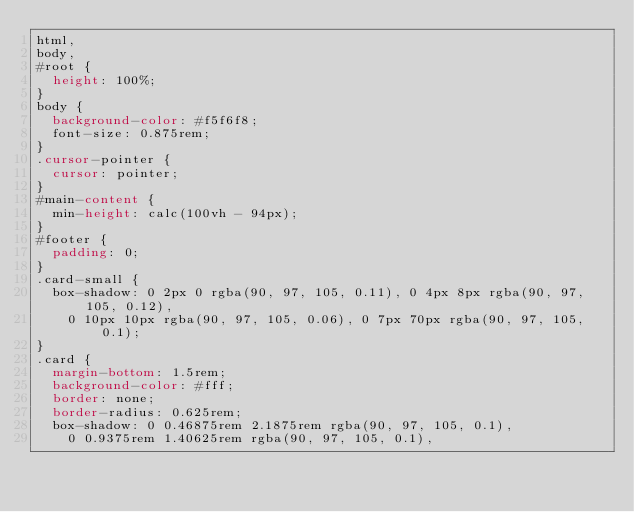<code> <loc_0><loc_0><loc_500><loc_500><_CSS_>html,
body,
#root {
  height: 100%;
}
body {
  background-color: #f5f6f8;
  font-size: 0.875rem;
}
.cursor-pointer {
  cursor: pointer;
}
#main-content {
  min-height: calc(100vh - 94px);
}
#footer {
  padding: 0;
}
.card-small {
  box-shadow: 0 2px 0 rgba(90, 97, 105, 0.11), 0 4px 8px rgba(90, 97, 105, 0.12),
    0 10px 10px rgba(90, 97, 105, 0.06), 0 7px 70px rgba(90, 97, 105, 0.1);
}
.card {
  margin-bottom: 1.5rem;
  background-color: #fff;
  border: none;
  border-radius: 0.625rem;
  box-shadow: 0 0.46875rem 2.1875rem rgba(90, 97, 105, 0.1),
    0 0.9375rem 1.40625rem rgba(90, 97, 105, 0.1),</code> 